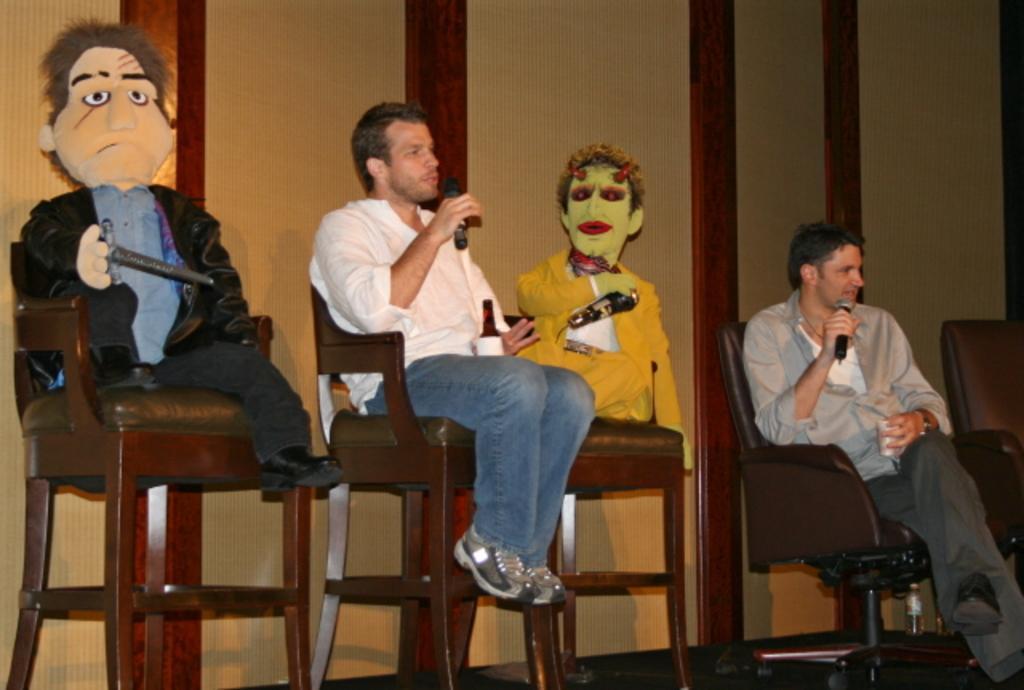How would you summarize this image in a sentence or two? there are 5 chairs. on the left brown chair there is a toy wearing a suit. right to it a person is sitting wearing a white shirt and a jeans, holding a microphone and a glass bottle in his hand. he is speaking. right to him there is a blue toy wearing a yellow suit. at the right corner a person is sitting, holding a microphone and speaking. he is holding a glass in his other hand. behind them there is a brown and a cream wall. 